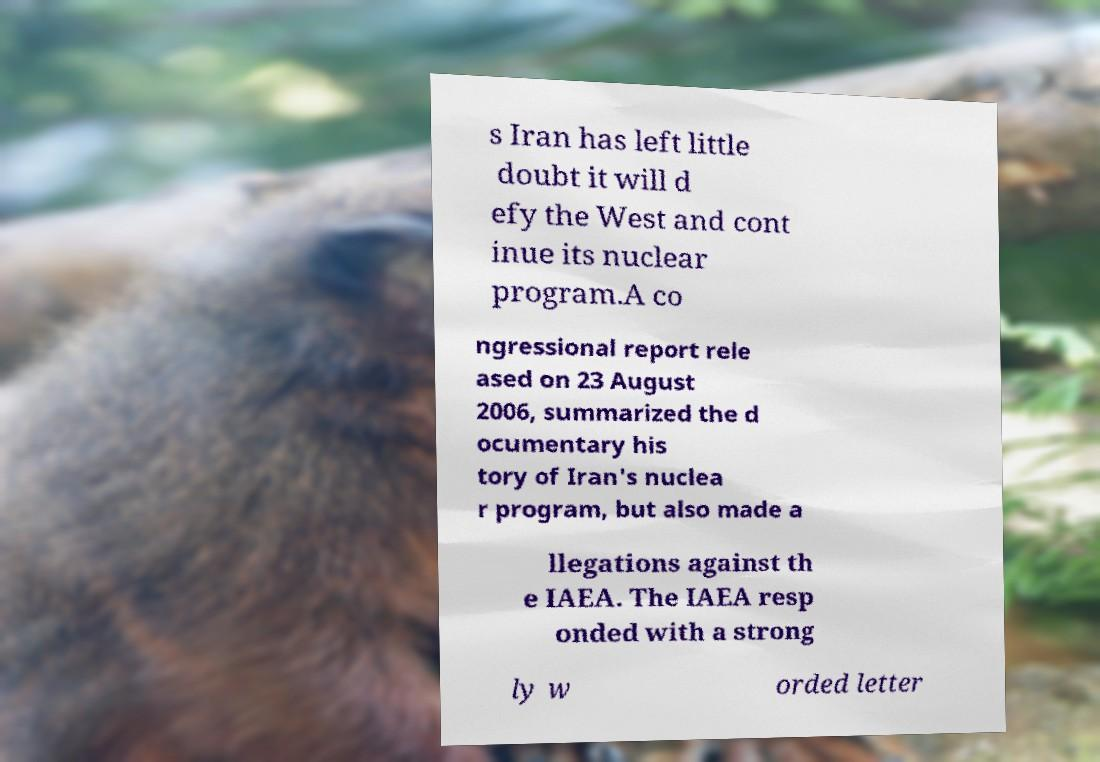Please identify and transcribe the text found in this image. s Iran has left little doubt it will d efy the West and cont inue its nuclear program.A co ngressional report rele ased on 23 August 2006, summarized the d ocumentary his tory of Iran's nuclea r program, but also made a llegations against th e IAEA. The IAEA resp onded with a strong ly w orded letter 